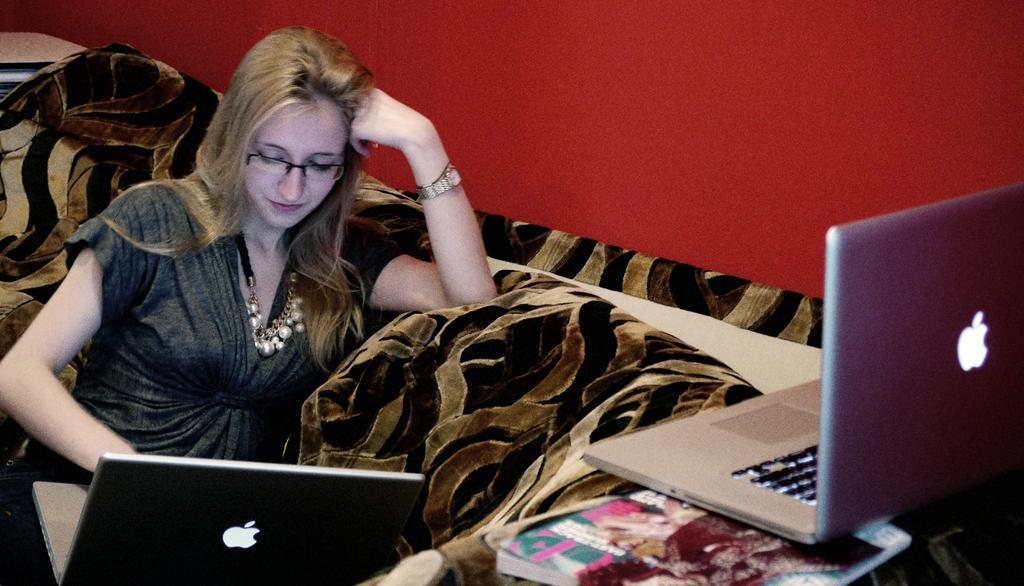Can you describe this image briefly? In this picture we can see a woman wore a spectacle, watch and sitting on a sofa, laptops, book and in the background we can see the red wall. 